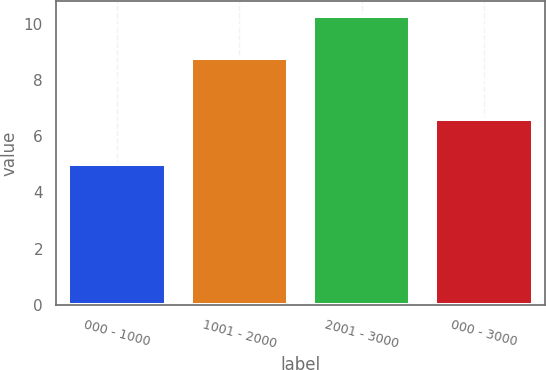<chart> <loc_0><loc_0><loc_500><loc_500><bar_chart><fcel>000 - 1000<fcel>1001 - 2000<fcel>2001 - 3000<fcel>000 - 3000<nl><fcel>5<fcel>8.8<fcel>10.3<fcel>6.6<nl></chart> 